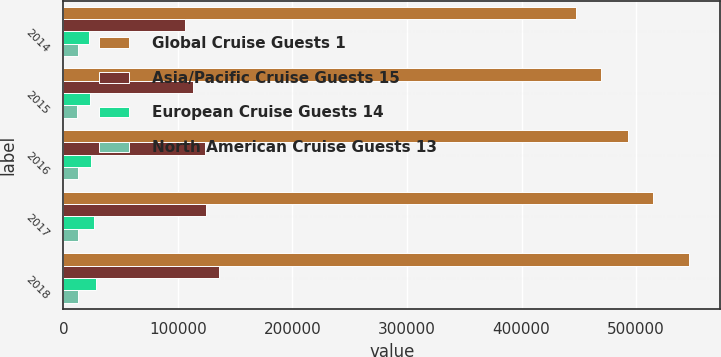Convert chart to OTSL. <chart><loc_0><loc_0><loc_500><loc_500><stacked_bar_chart><ecel><fcel>2014<fcel>2015<fcel>2016<fcel>2017<fcel>2018<nl><fcel>Global Cruise Guests 1<fcel>448000<fcel>469000<fcel>493000<fcel>515000<fcel>546000<nl><fcel>Asia/Pacific Cruise Guests 15<fcel>105750<fcel>112700<fcel>123270<fcel>124070<fcel>135520<nl><fcel>European Cruise Guests 14<fcel>22039<fcel>23000<fcel>24000<fcel>26700<fcel>28000<nl><fcel>North American Cruise Guests 13<fcel>12269<fcel>12004<fcel>12274<fcel>12865<fcel>13054<nl></chart> 